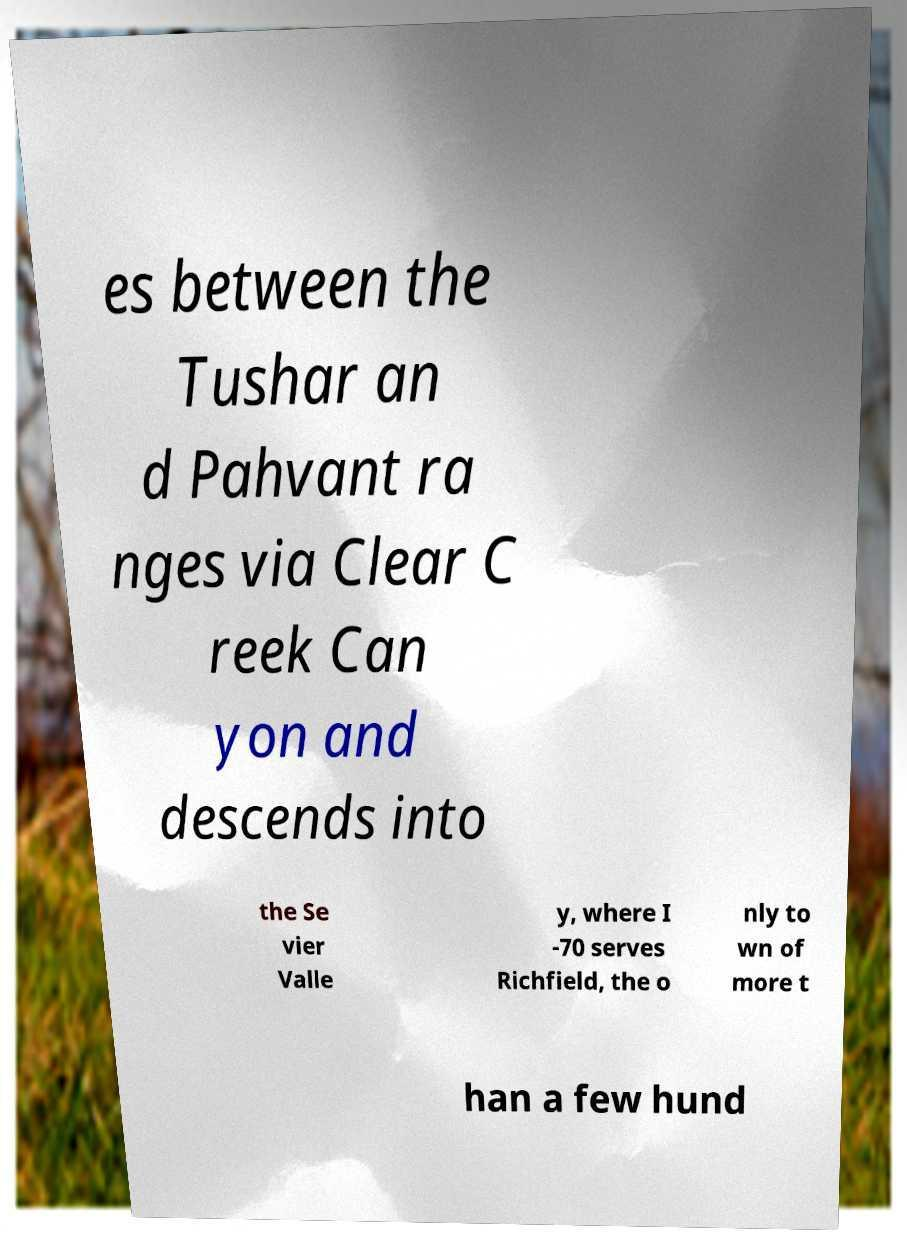Could you extract and type out the text from this image? es between the Tushar an d Pahvant ra nges via Clear C reek Can yon and descends into the Se vier Valle y, where I -70 serves Richfield, the o nly to wn of more t han a few hund 